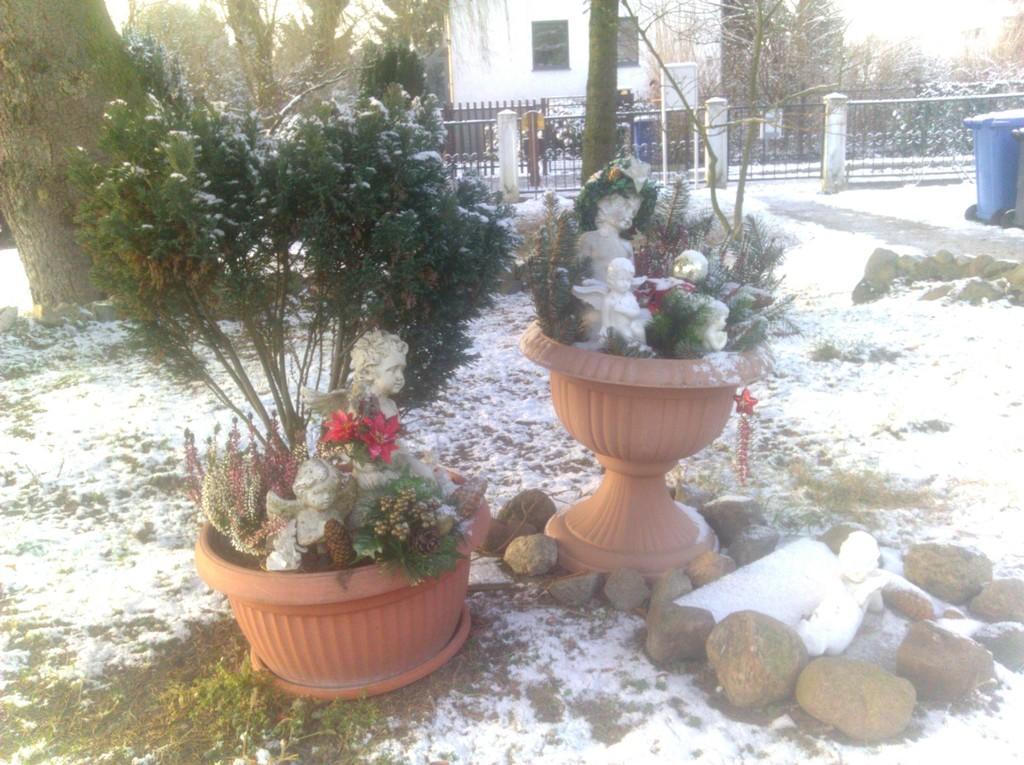How would you summarize this image in a sentence or two? In this picture I can see the plants and pots. On the right I can see some statues, beside that I can see many stones and snow. In the back there is a building. In front of the building I can see the gate and fencing. On the right there is a dustbin near to the road. In the top left I can see the sky. In the background I can see many trees. 